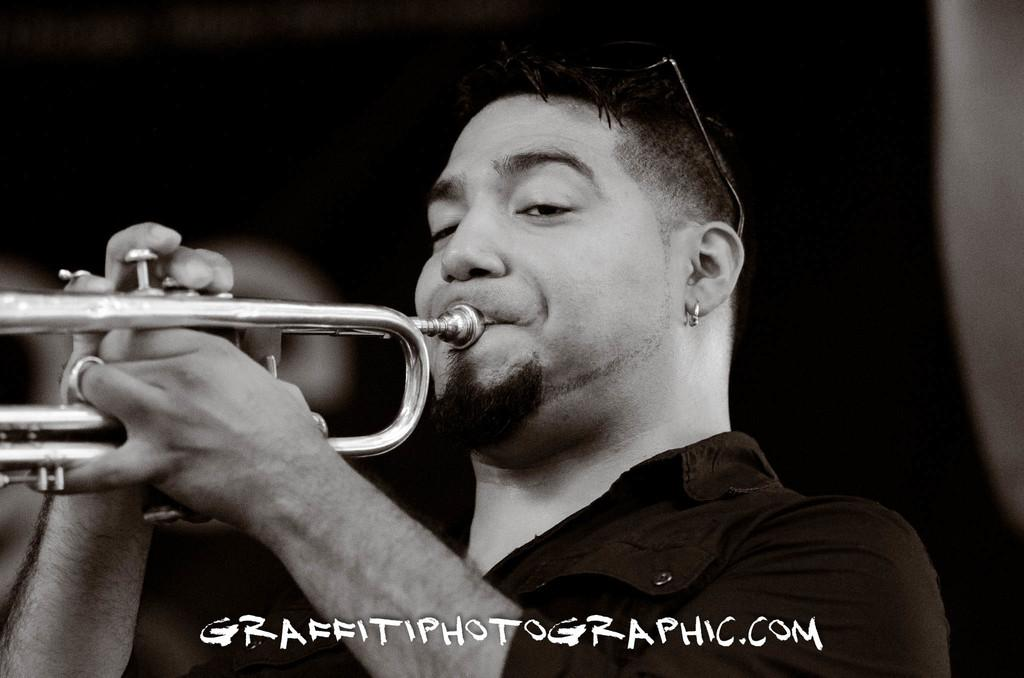What is the main subject of the image? There is a person in the image. What is the person wearing? The person is wearing a t-shirt. What is the person doing with their hands? The person is holding a musical instrument with both hands. What activity is the person engaged in? The person is playing the musical instrument. How would you describe the background of the image? The background of the image is dark in color. Can you see any islands or oceans in the image? No, there are no islands or oceans present in the image. 